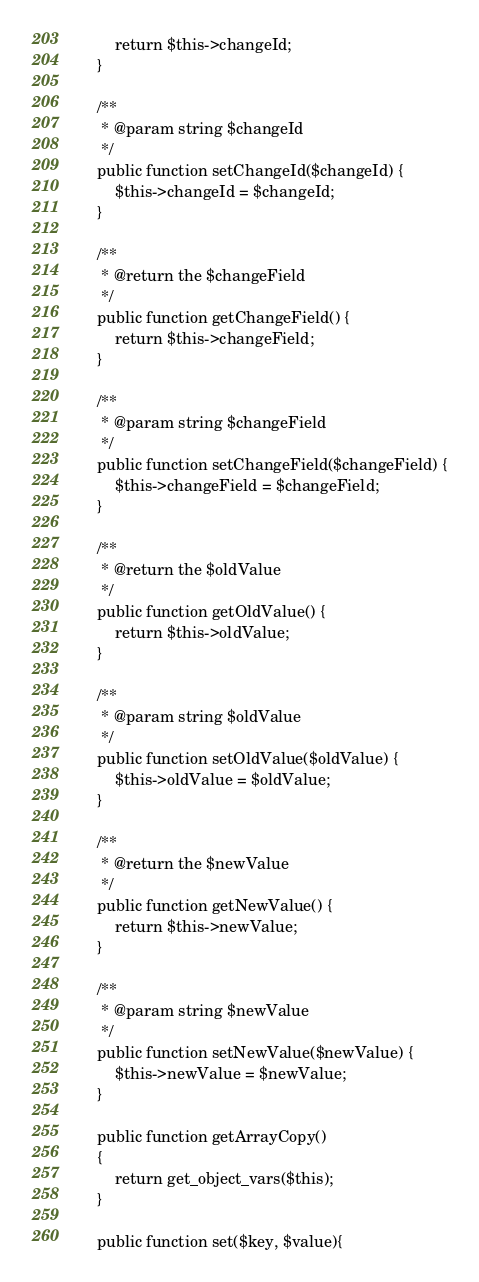Convert code to text. <code><loc_0><loc_0><loc_500><loc_500><_PHP_>        return $this->changeId;
    }

    /**
     * @param string $changeId
     */
    public function setChangeId($changeId) {
        $this->changeId = $changeId;
    }

    /**
     * @return the $changeField
     */
    public function getChangeField() {
        return $this->changeField;
    }

    /**
     * @param string $changeField
     */
    public function setChangeField($changeField) {
        $this->changeField = $changeField;
    }
    
    /**
     * @return the $oldValue
     */
    public function getOldValue() {
        return $this->oldValue;
    }

    /**
     * @param string $oldValue
     */
    public function setOldValue($oldValue) {
        $this->oldValue = $oldValue;
    }
    
    /**
     * @return the $newValue
     */
    public function getNewValue() {
        return $this->newValue;
    }

    /**
     * @param string $newValue
     */
    public function setNewValue($newValue) {
        $this->newValue = $newValue;
    }

    public function getArrayCopy()
    {
        return get_object_vars($this);
    }
    
    public function set($key, $value){</code> 